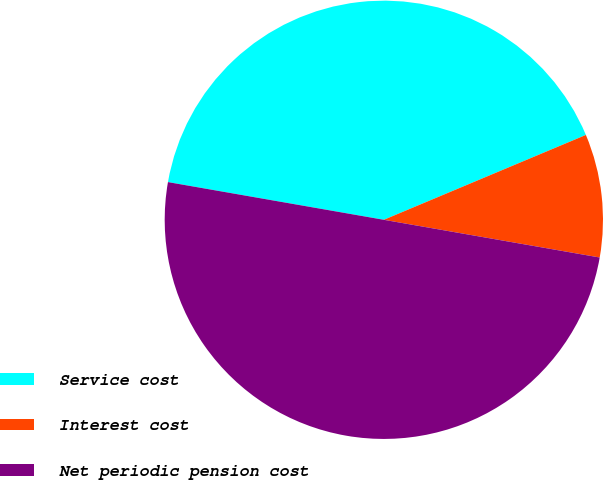Convert chart. <chart><loc_0><loc_0><loc_500><loc_500><pie_chart><fcel>Service cost<fcel>Interest cost<fcel>Net periodic pension cost<nl><fcel>40.92%<fcel>9.08%<fcel>50.0%<nl></chart> 